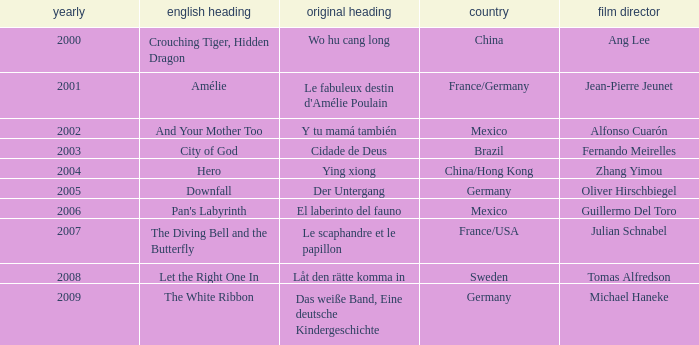Tell me the country for julian schnabel France/USA. 